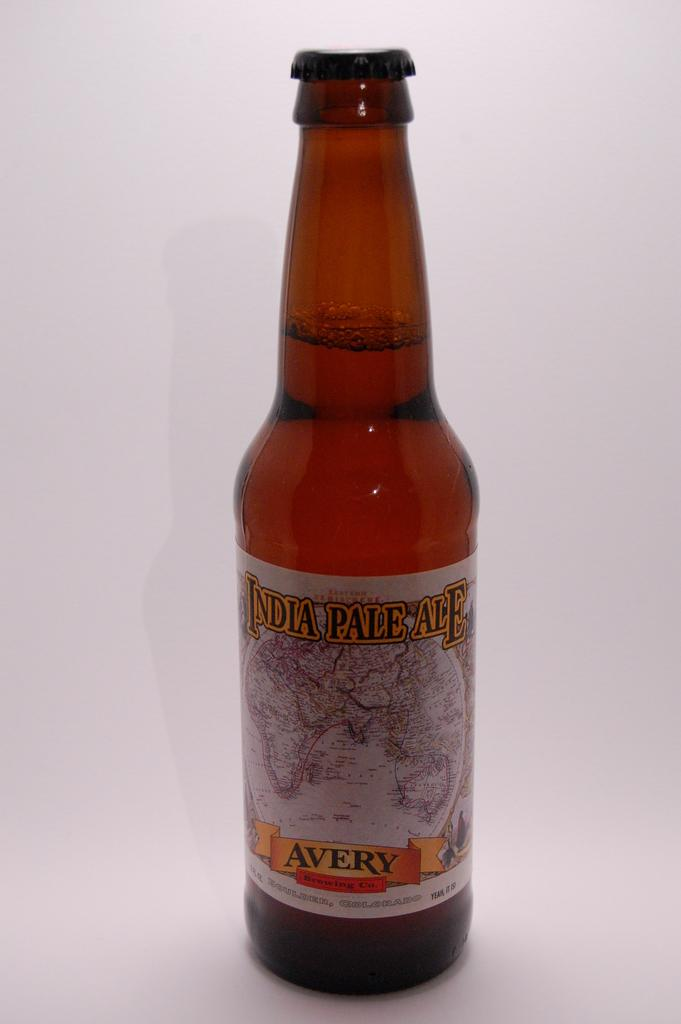<image>
Relay a brief, clear account of the picture shown. a bottle of avery india pale ale, still closed 